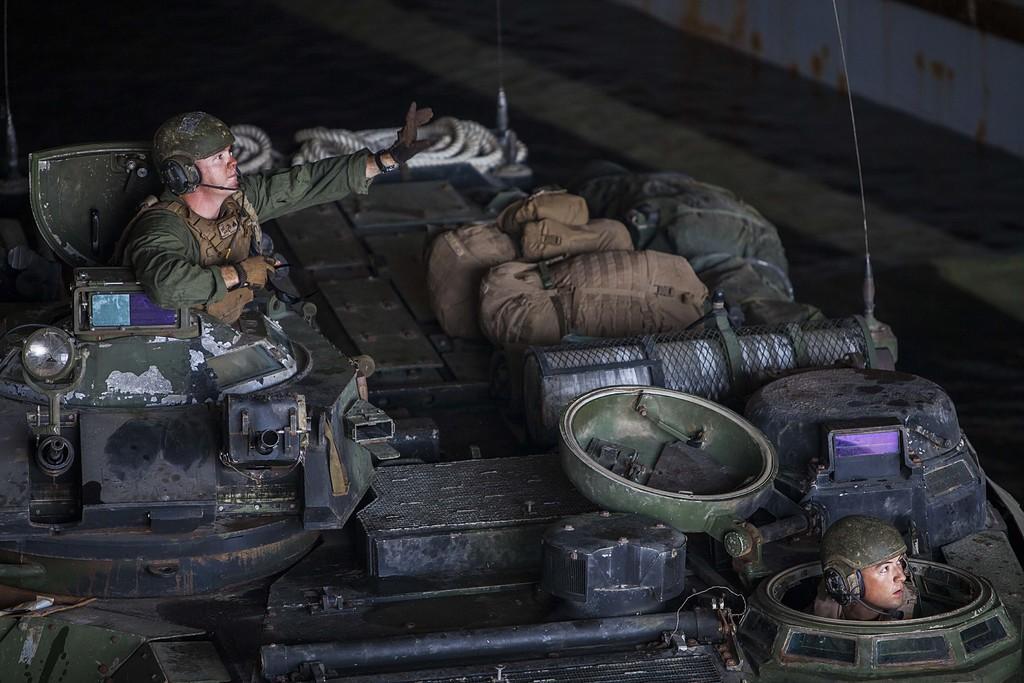Could you give a brief overview of what you see in this image? As we can see in the image there are two people wearing army dresses and helmets. There is a rope and bags. The image is little dark. 